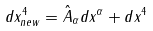<formula> <loc_0><loc_0><loc_500><loc_500>d x _ { n e w } ^ { 4 } = \hat { A } _ { \alpha } d x ^ { \alpha } + d x ^ { 4 }</formula> 